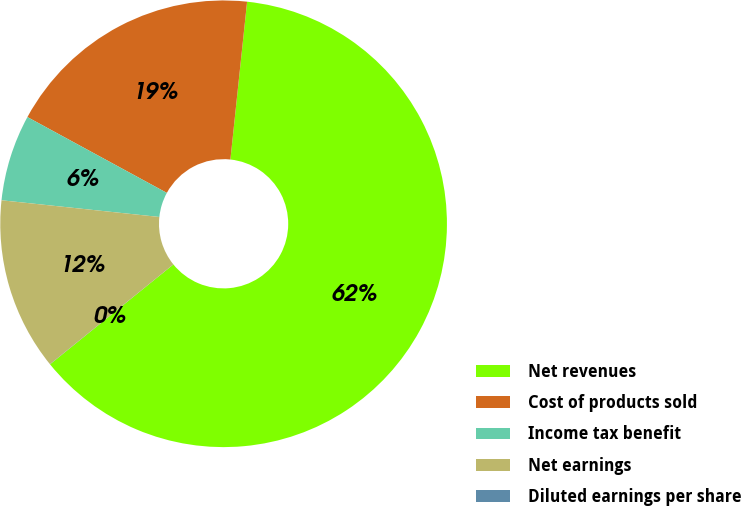Convert chart to OTSL. <chart><loc_0><loc_0><loc_500><loc_500><pie_chart><fcel>Net revenues<fcel>Cost of products sold<fcel>Income tax benefit<fcel>Net earnings<fcel>Diluted earnings per share<nl><fcel>62.49%<fcel>18.75%<fcel>6.25%<fcel>12.5%<fcel>0.01%<nl></chart> 